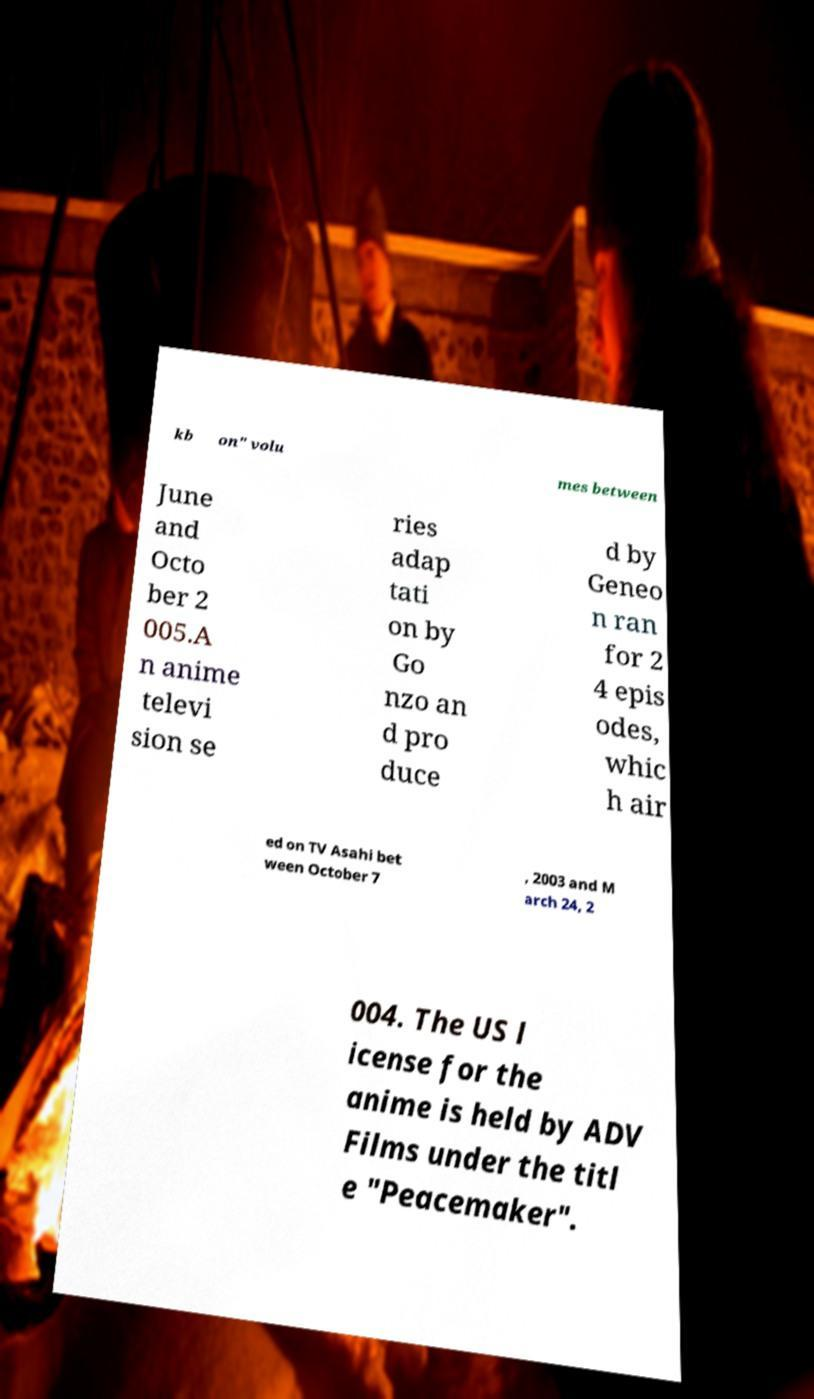Please read and relay the text visible in this image. What does it say? kb on" volu mes between June and Octo ber 2 005.A n anime televi sion se ries adap tati on by Go nzo an d pro duce d by Geneo n ran for 2 4 epis odes, whic h air ed on TV Asahi bet ween October 7 , 2003 and M arch 24, 2 004. The US l icense for the anime is held by ADV Films under the titl e "Peacemaker". 